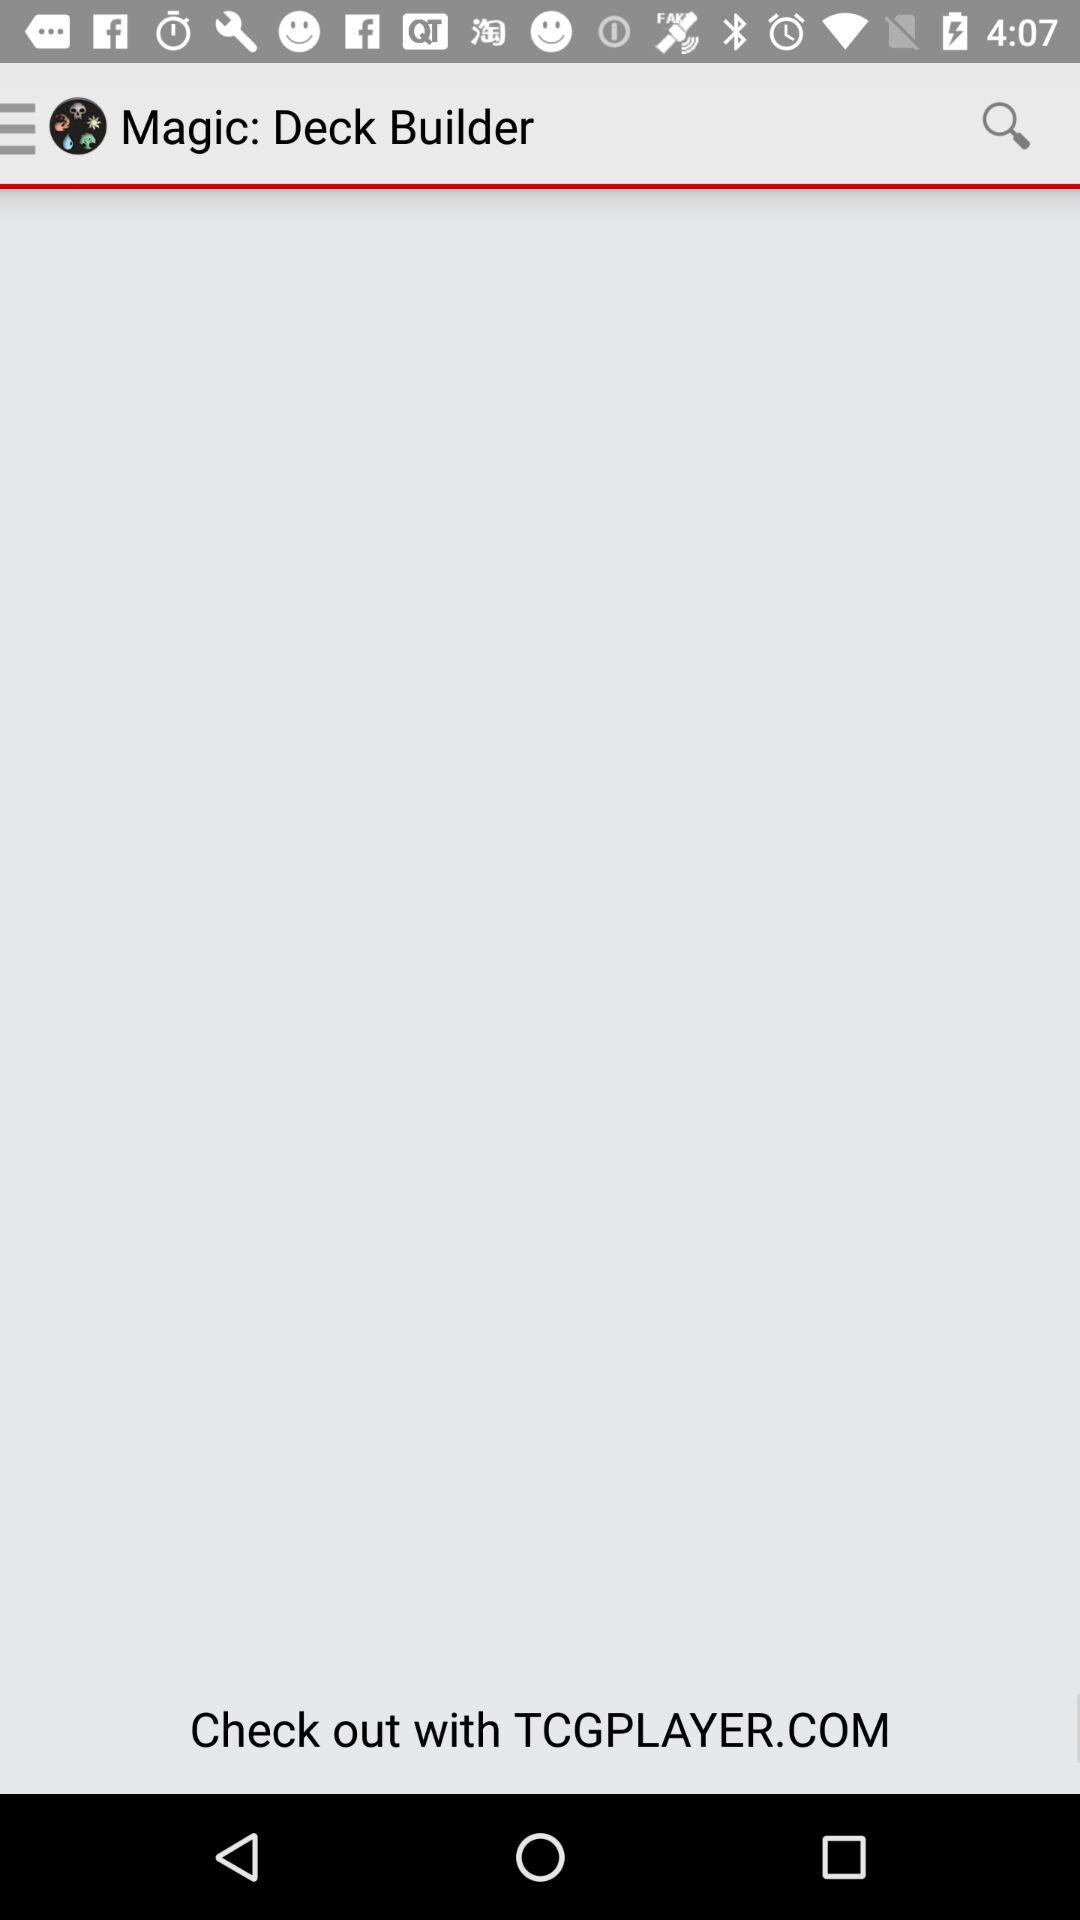What is the year mentioned for magic? The year mentioned for magic is 2012. 